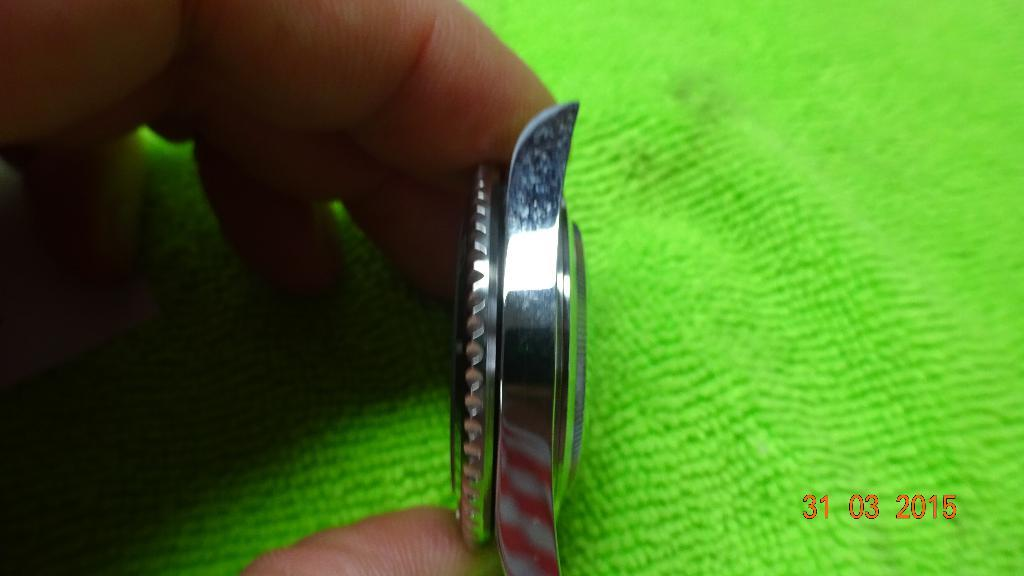<image>
Write a terse but informative summary of the picture. the number 31 and a person holding a metal piece 